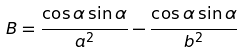<formula> <loc_0><loc_0><loc_500><loc_500>B = \frac { \cos \alpha \sin \alpha } { a ^ { 2 } } - \frac { \cos \alpha \sin \alpha } { b ^ { 2 } }</formula> 